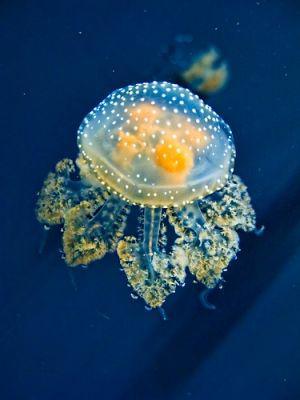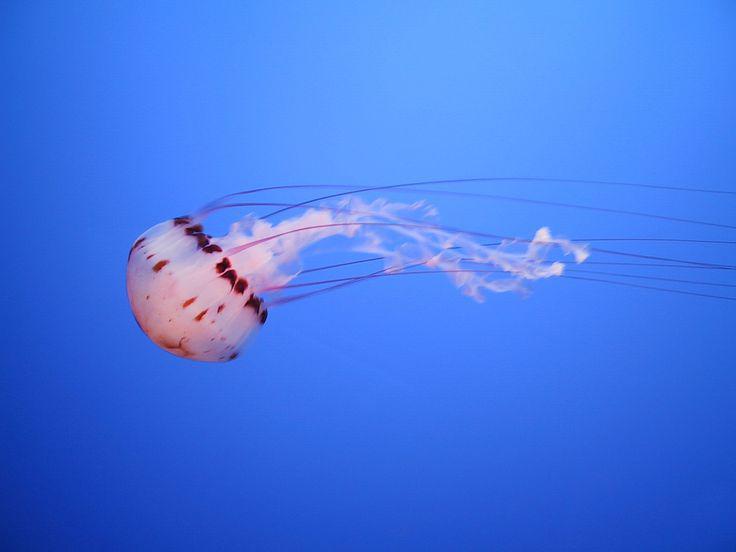The first image is the image on the left, the second image is the image on the right. Assess this claim about the two images: "At least one jellyfish has a polka dot body.". Correct or not? Answer yes or no. Yes. 